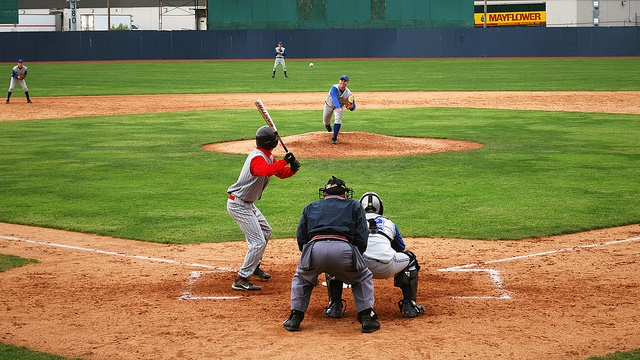Describe the objects in this image and their specific colors. I can see people in teal, black, and gray tones, people in teal, darkgray, gray, black, and lightgray tones, people in teal, black, lightgray, gray, and darkgray tones, people in teal, darkgray, black, lightgray, and gray tones, and people in teal, gray, black, darkgray, and darkgreen tones in this image. 